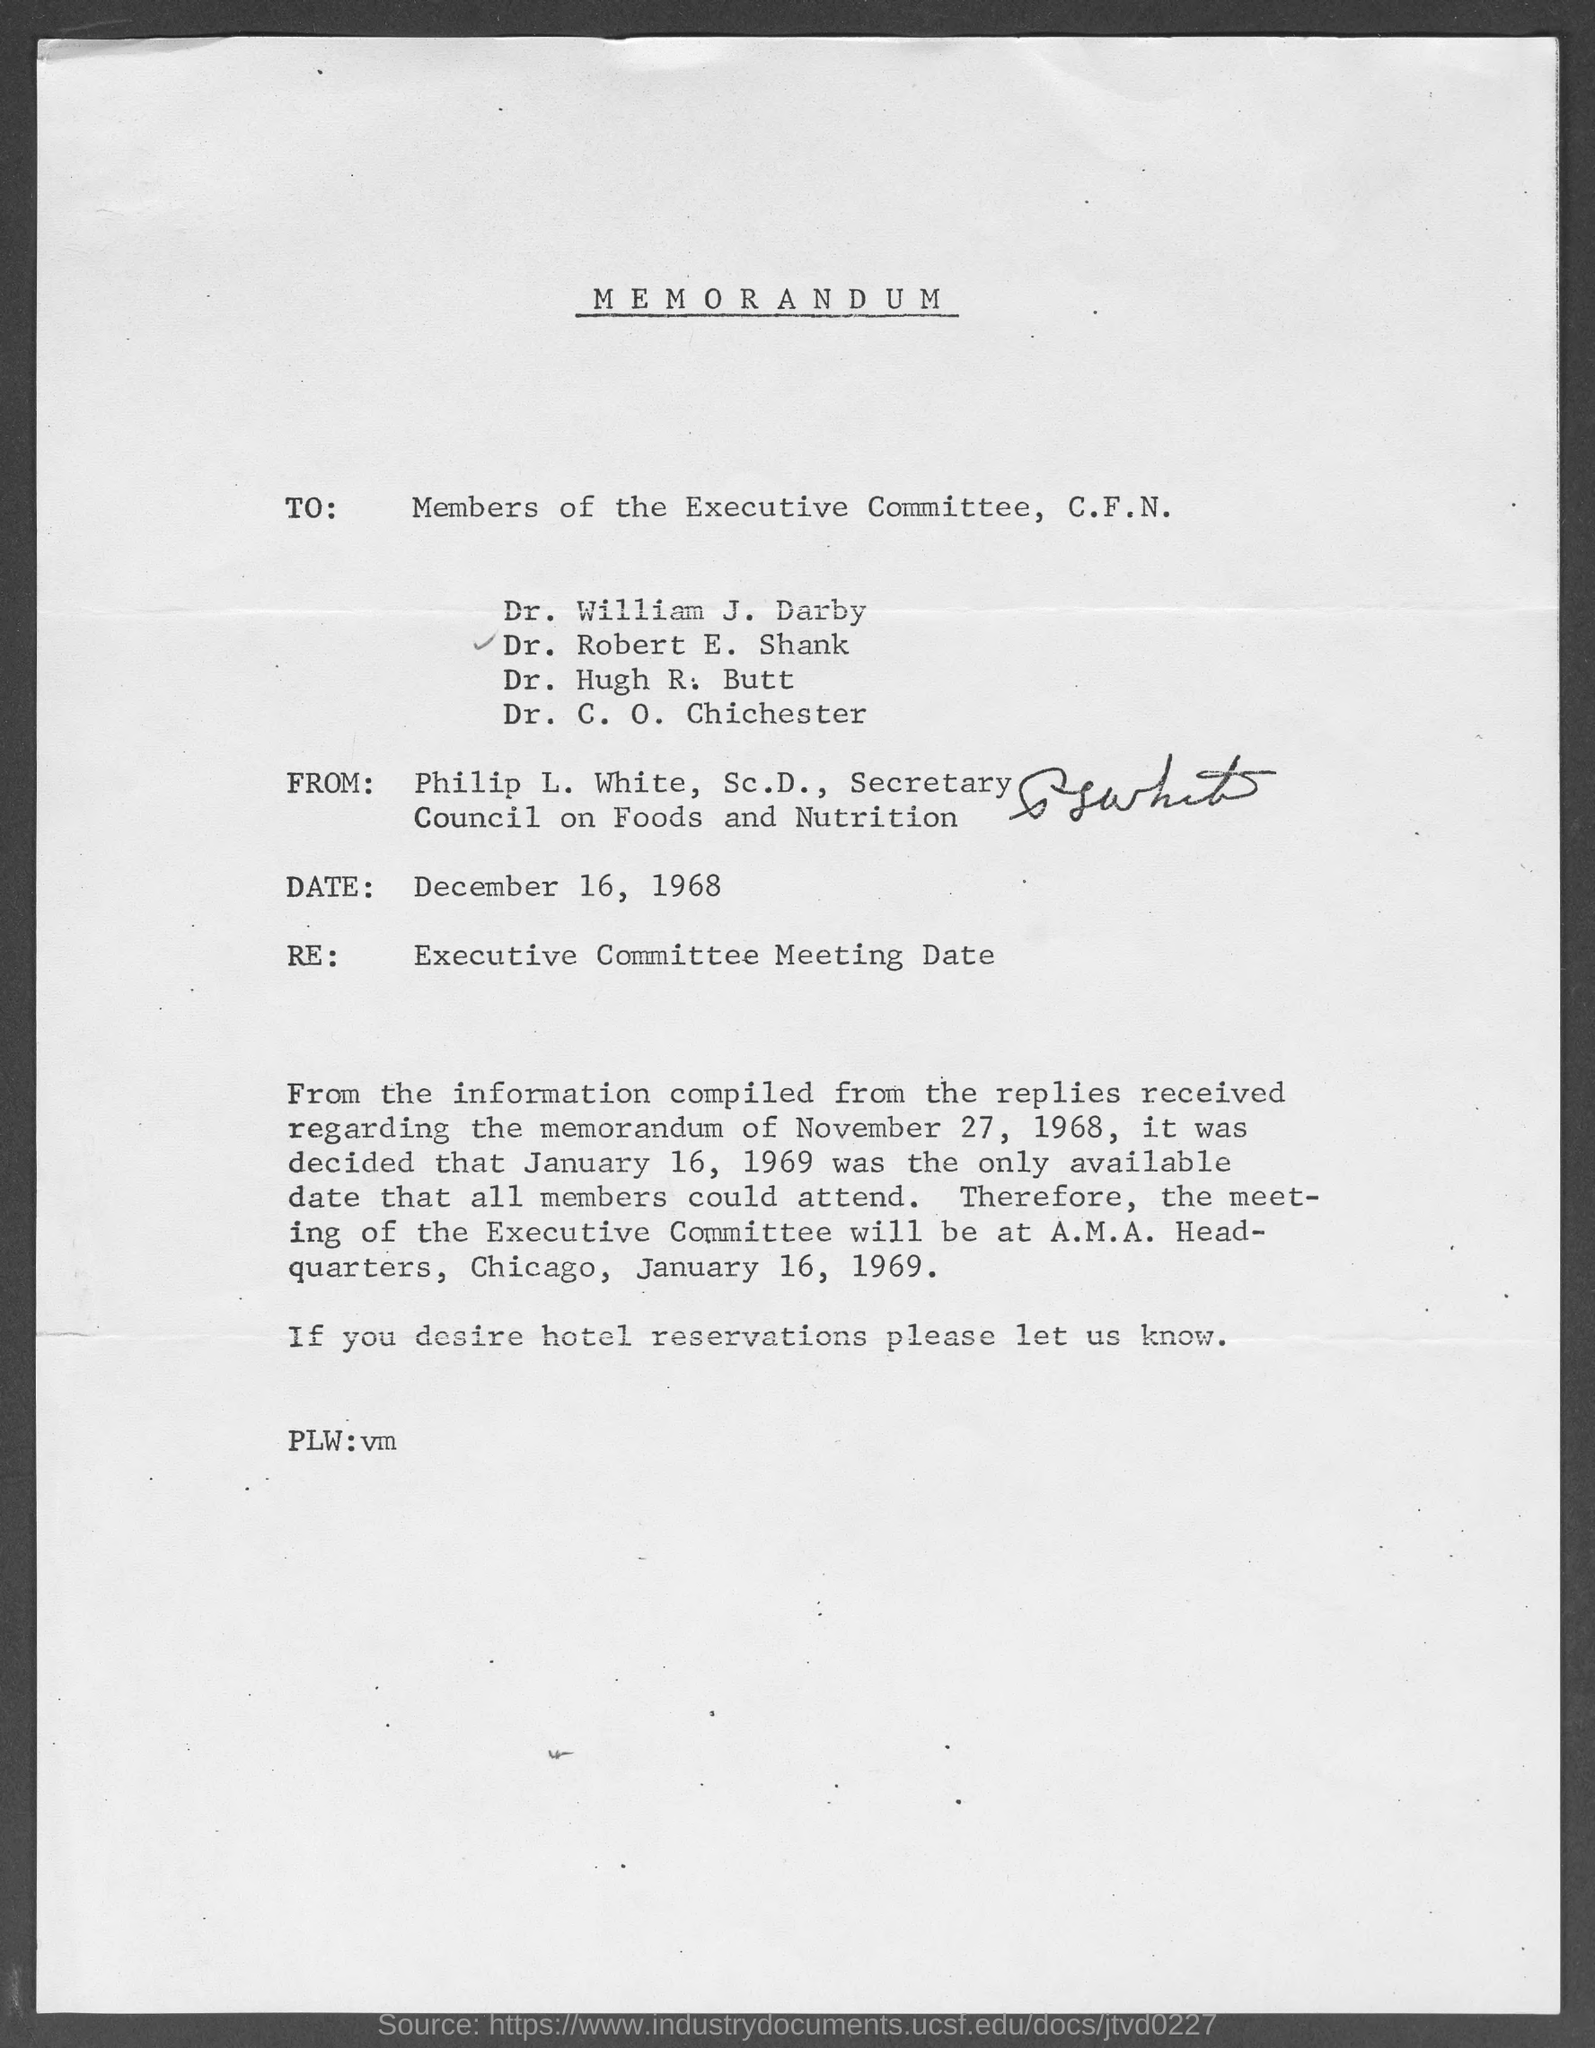What type of documentation is this?
Keep it short and to the point. MEMORANDUM. When is the document dated?
Provide a succinct answer. December 16, 1968. Who is the Secretary Council on Foods and Nutrition?
Provide a short and direct response. Philip L. White. When is the meeting going to be held?
Your response must be concise. January 16, 1969. 